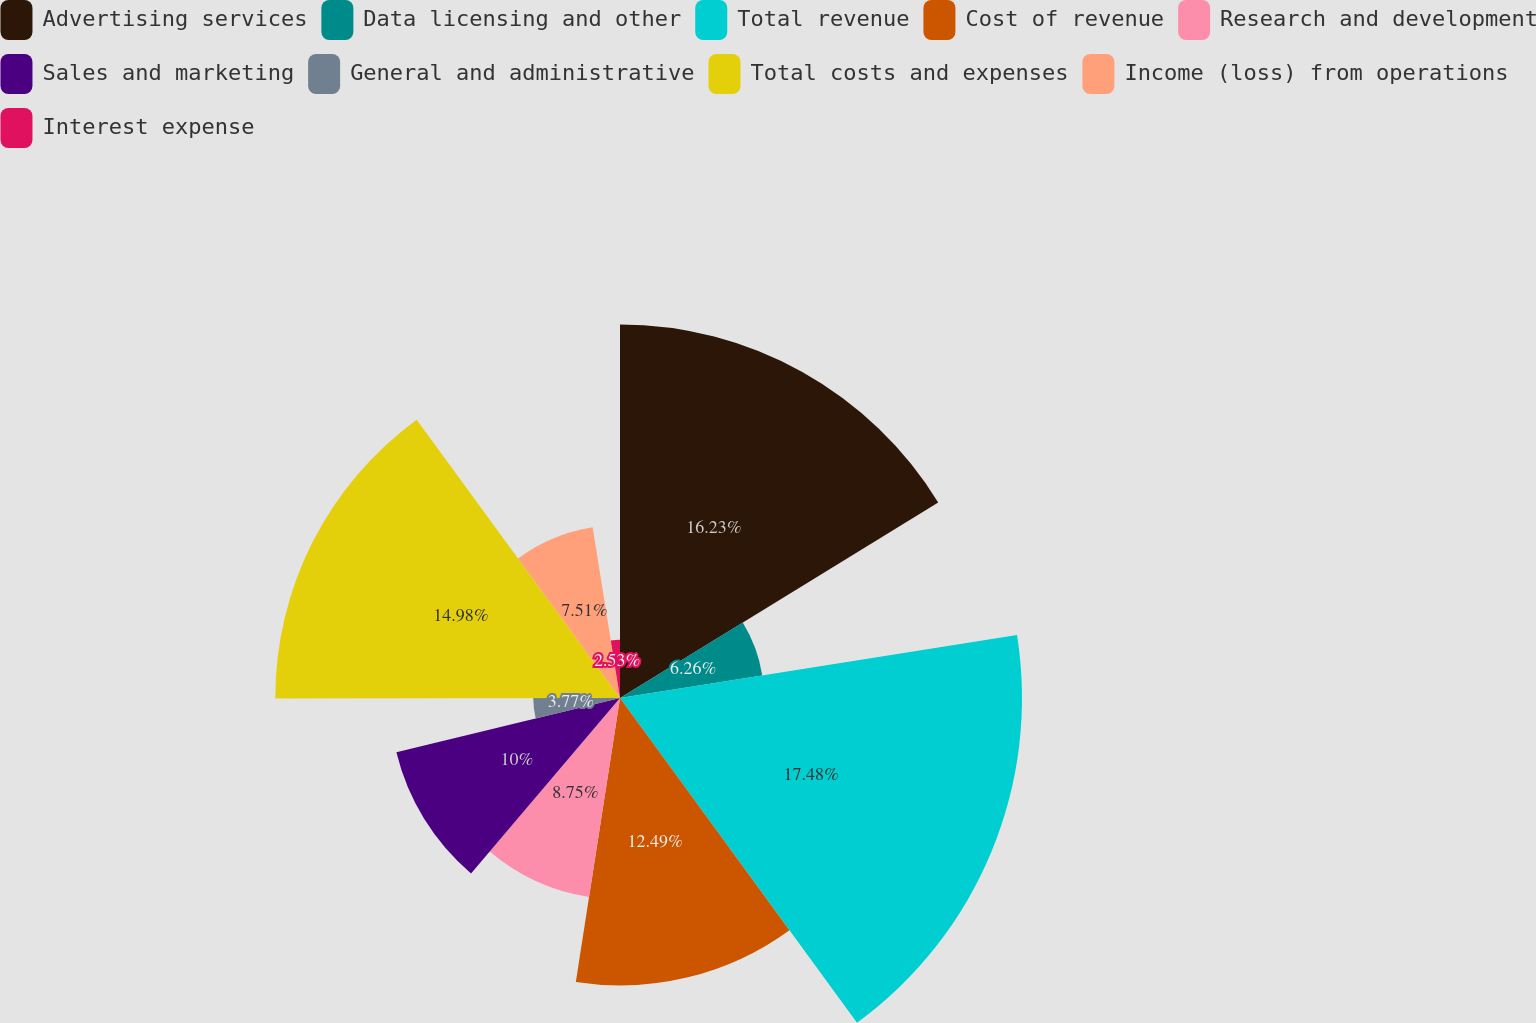Convert chart to OTSL. <chart><loc_0><loc_0><loc_500><loc_500><pie_chart><fcel>Advertising services<fcel>Data licensing and other<fcel>Total revenue<fcel>Cost of revenue<fcel>Research and development<fcel>Sales and marketing<fcel>General and administrative<fcel>Total costs and expenses<fcel>Income (loss) from operations<fcel>Interest expense<nl><fcel>16.23%<fcel>6.26%<fcel>17.47%<fcel>12.49%<fcel>8.75%<fcel>10.0%<fcel>3.77%<fcel>14.98%<fcel>7.51%<fcel>2.53%<nl></chart> 